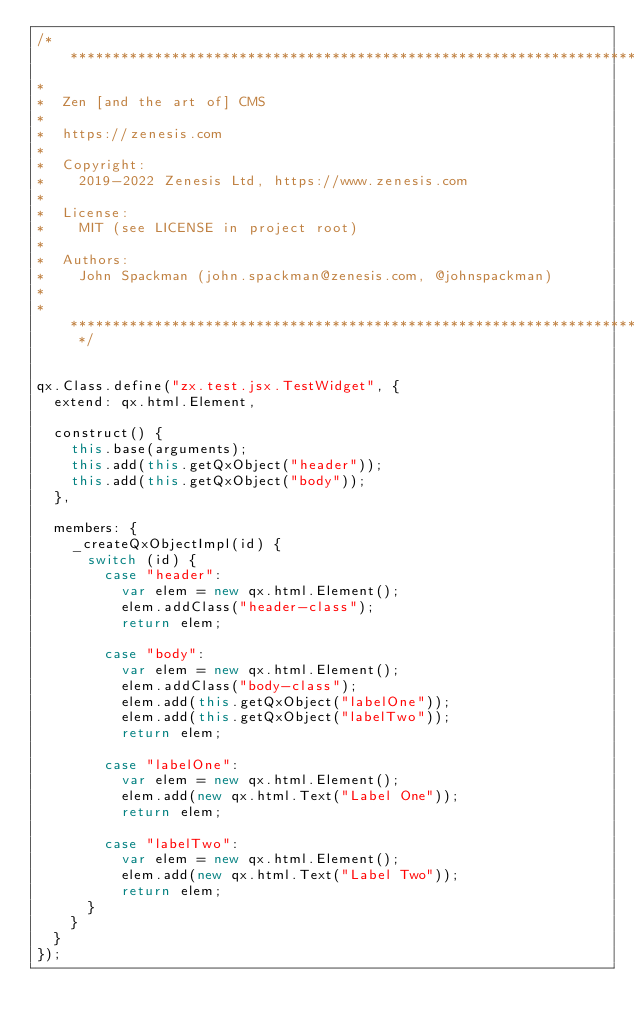Convert code to text. <code><loc_0><loc_0><loc_500><loc_500><_JavaScript_>/* ************************************************************************
*
*  Zen [and the art of] CMS
*
*  https://zenesis.com
*
*  Copyright:
*    2019-2022 Zenesis Ltd, https://www.zenesis.com
*
*  License:
*    MIT (see LICENSE in project root)
*
*  Authors:
*    John Spackman (john.spackman@zenesis.com, @johnspackman)
*
* ************************************************************************ */


qx.Class.define("zx.test.jsx.TestWidget", {
  extend: qx.html.Element,

  construct() {
    this.base(arguments);
    this.add(this.getQxObject("header"));
    this.add(this.getQxObject("body"));
  },

  members: {
    _createQxObjectImpl(id) {
      switch (id) {
        case "header":
          var elem = new qx.html.Element();
          elem.addClass("header-class");
          return elem;

        case "body":
          var elem = new qx.html.Element();
          elem.addClass("body-class");
          elem.add(this.getQxObject("labelOne"));
          elem.add(this.getQxObject("labelTwo"));
          return elem;

        case "labelOne":
          var elem = new qx.html.Element();
          elem.add(new qx.html.Text("Label One"));
          return elem;

        case "labelTwo":
          var elem = new qx.html.Element();
          elem.add(new qx.html.Text("Label Two"));
          return elem;
      }
    }
  }
});
</code> 